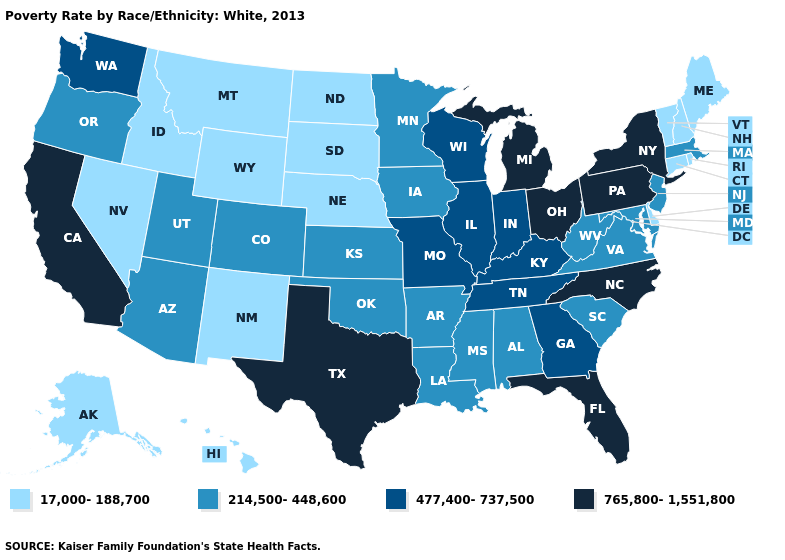Is the legend a continuous bar?
Concise answer only. No. Is the legend a continuous bar?
Write a very short answer. No. Does the first symbol in the legend represent the smallest category?
Concise answer only. Yes. Name the states that have a value in the range 214,500-448,600?
Answer briefly. Alabama, Arizona, Arkansas, Colorado, Iowa, Kansas, Louisiana, Maryland, Massachusetts, Minnesota, Mississippi, New Jersey, Oklahoma, Oregon, South Carolina, Utah, Virginia, West Virginia. Among the states that border Kansas , which have the lowest value?
Write a very short answer. Nebraska. Among the states that border West Virginia , which have the highest value?
Quick response, please. Ohio, Pennsylvania. Name the states that have a value in the range 214,500-448,600?
Write a very short answer. Alabama, Arizona, Arkansas, Colorado, Iowa, Kansas, Louisiana, Maryland, Massachusetts, Minnesota, Mississippi, New Jersey, Oklahoma, Oregon, South Carolina, Utah, Virginia, West Virginia. Does North Carolina have the same value as New York?
Quick response, please. Yes. What is the value of Maryland?
Short answer required. 214,500-448,600. Name the states that have a value in the range 477,400-737,500?
Give a very brief answer. Georgia, Illinois, Indiana, Kentucky, Missouri, Tennessee, Washington, Wisconsin. What is the value of Maryland?
Concise answer only. 214,500-448,600. What is the value of South Dakota?
Concise answer only. 17,000-188,700. Does Utah have a lower value than New Jersey?
Write a very short answer. No. Which states have the lowest value in the USA?
Give a very brief answer. Alaska, Connecticut, Delaware, Hawaii, Idaho, Maine, Montana, Nebraska, Nevada, New Hampshire, New Mexico, North Dakota, Rhode Island, South Dakota, Vermont, Wyoming. 